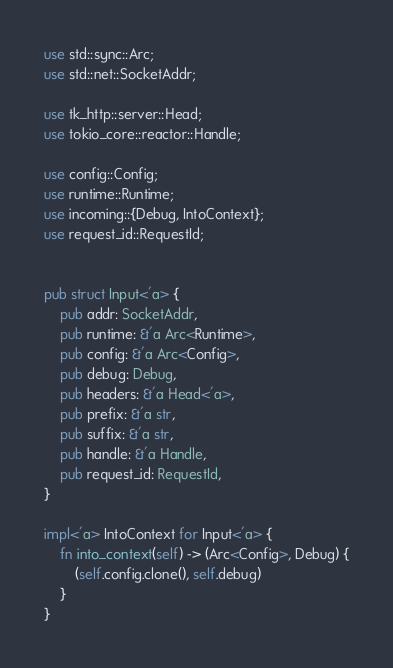Convert code to text. <code><loc_0><loc_0><loc_500><loc_500><_Rust_>use std::sync::Arc;
use std::net::SocketAddr;

use tk_http::server::Head;
use tokio_core::reactor::Handle;

use config::Config;
use runtime::Runtime;
use incoming::{Debug, IntoContext};
use request_id::RequestId;


pub struct Input<'a> {
    pub addr: SocketAddr,
    pub runtime: &'a Arc<Runtime>,
    pub config: &'a Arc<Config>,
    pub debug: Debug,
    pub headers: &'a Head<'a>,
    pub prefix: &'a str,
    pub suffix: &'a str,
    pub handle: &'a Handle,
    pub request_id: RequestId,
}

impl<'a> IntoContext for Input<'a> {
    fn into_context(self) -> (Arc<Config>, Debug) {
        (self.config.clone(), self.debug)
    }
}
</code> 